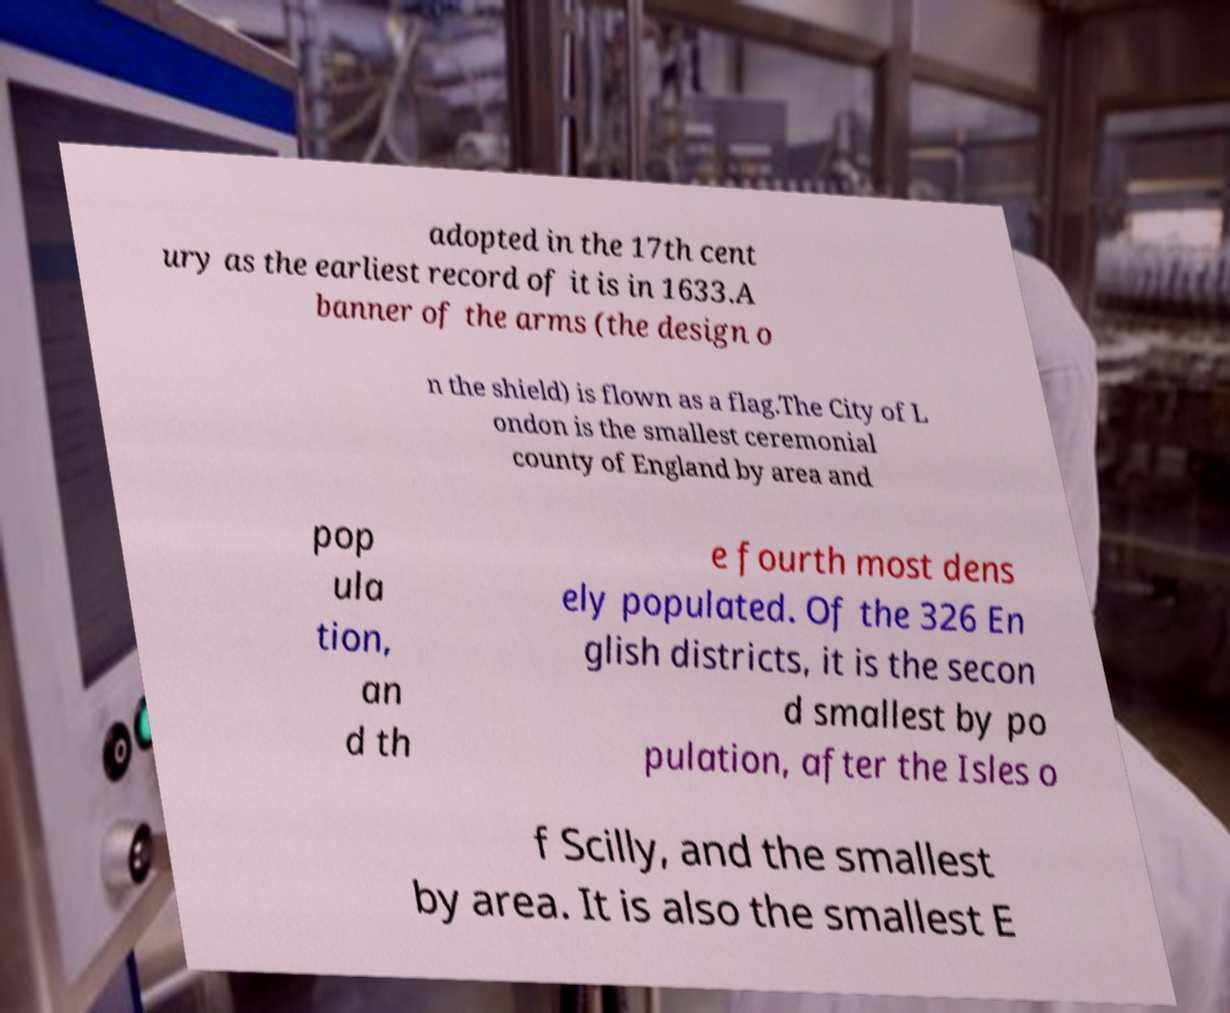Can you read and provide the text displayed in the image?This photo seems to have some interesting text. Can you extract and type it out for me? adopted in the 17th cent ury as the earliest record of it is in 1633.A banner of the arms (the design o n the shield) is flown as a flag.The City of L ondon is the smallest ceremonial county of England by area and pop ula tion, an d th e fourth most dens ely populated. Of the 326 En glish districts, it is the secon d smallest by po pulation, after the Isles o f Scilly, and the smallest by area. It is also the smallest E 